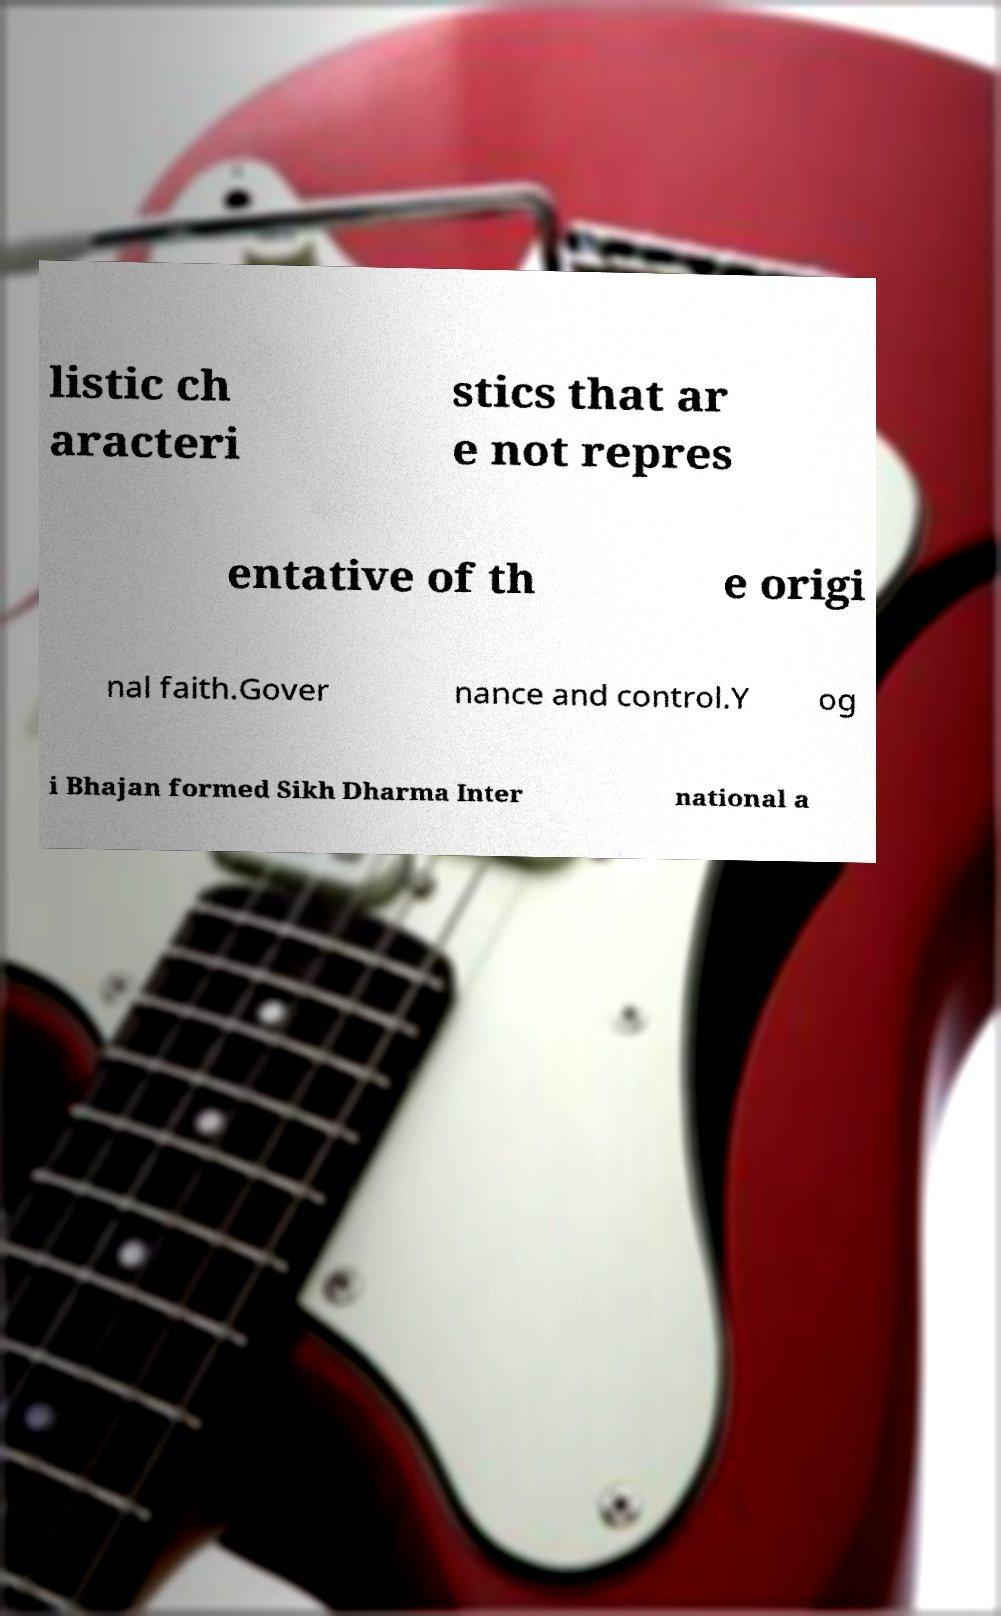Can you read and provide the text displayed in the image?This photo seems to have some interesting text. Can you extract and type it out for me? listic ch aracteri stics that ar e not repres entative of th e origi nal faith.Gover nance and control.Y og i Bhajan formed Sikh Dharma Inter national a 